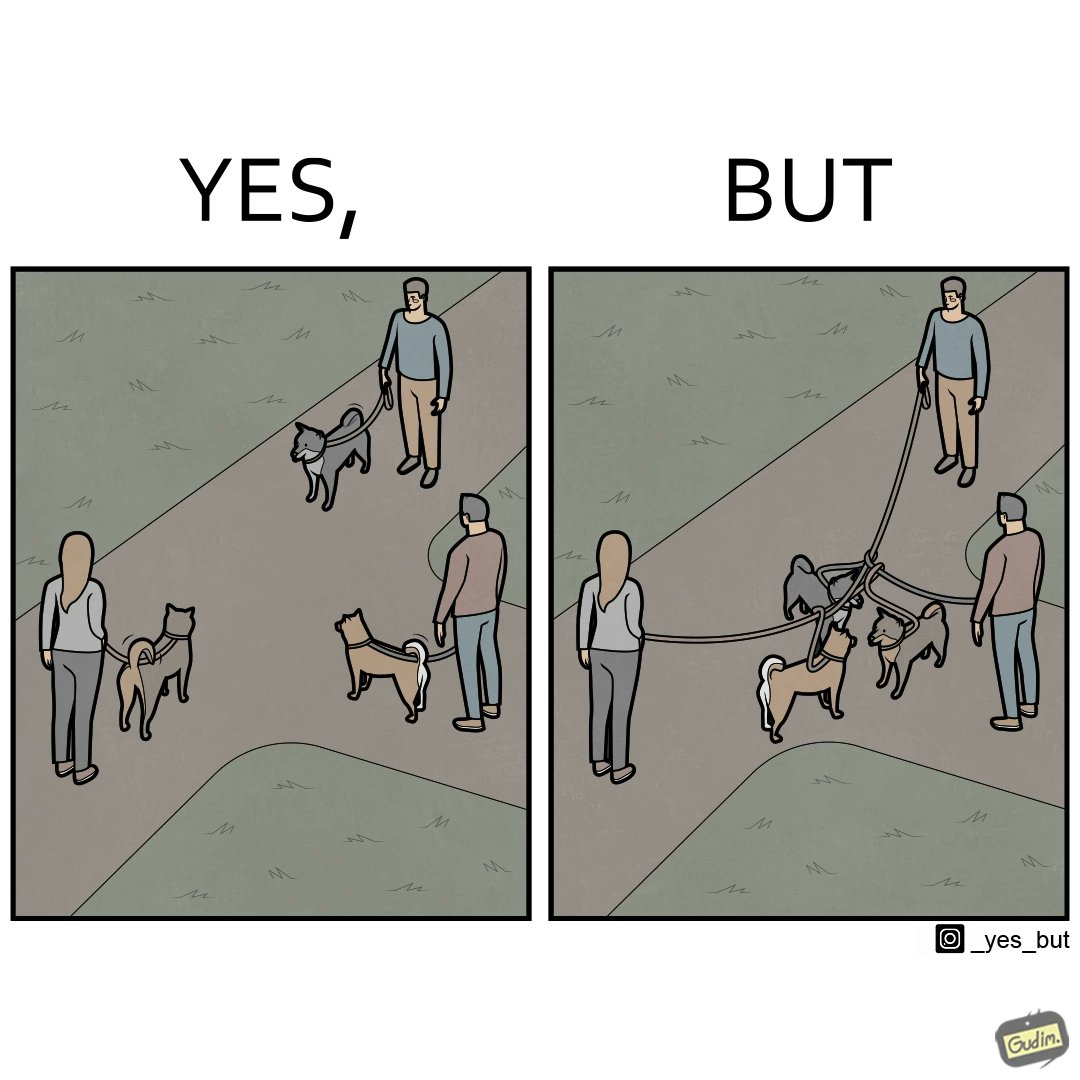Would you classify this image as satirical? Yes, this image is satirical. 